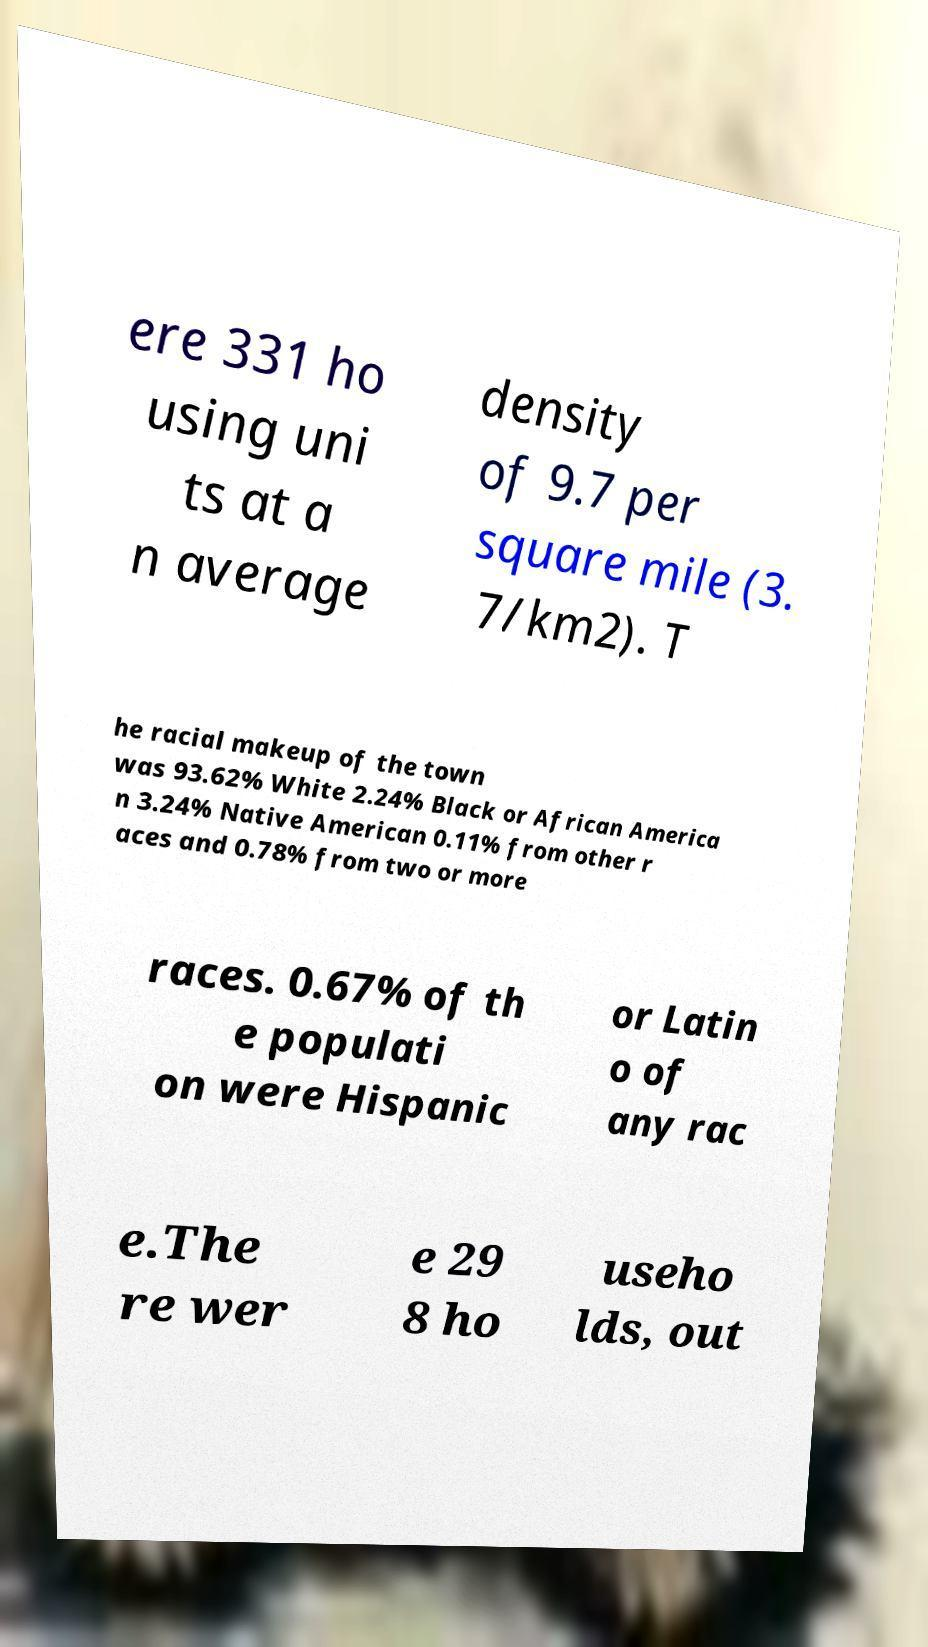Can you read and provide the text displayed in the image?This photo seems to have some interesting text. Can you extract and type it out for me? ere 331 ho using uni ts at a n average density of 9.7 per square mile (3. 7/km2). T he racial makeup of the town was 93.62% White 2.24% Black or African America n 3.24% Native American 0.11% from other r aces and 0.78% from two or more races. 0.67% of th e populati on were Hispanic or Latin o of any rac e.The re wer e 29 8 ho useho lds, out 